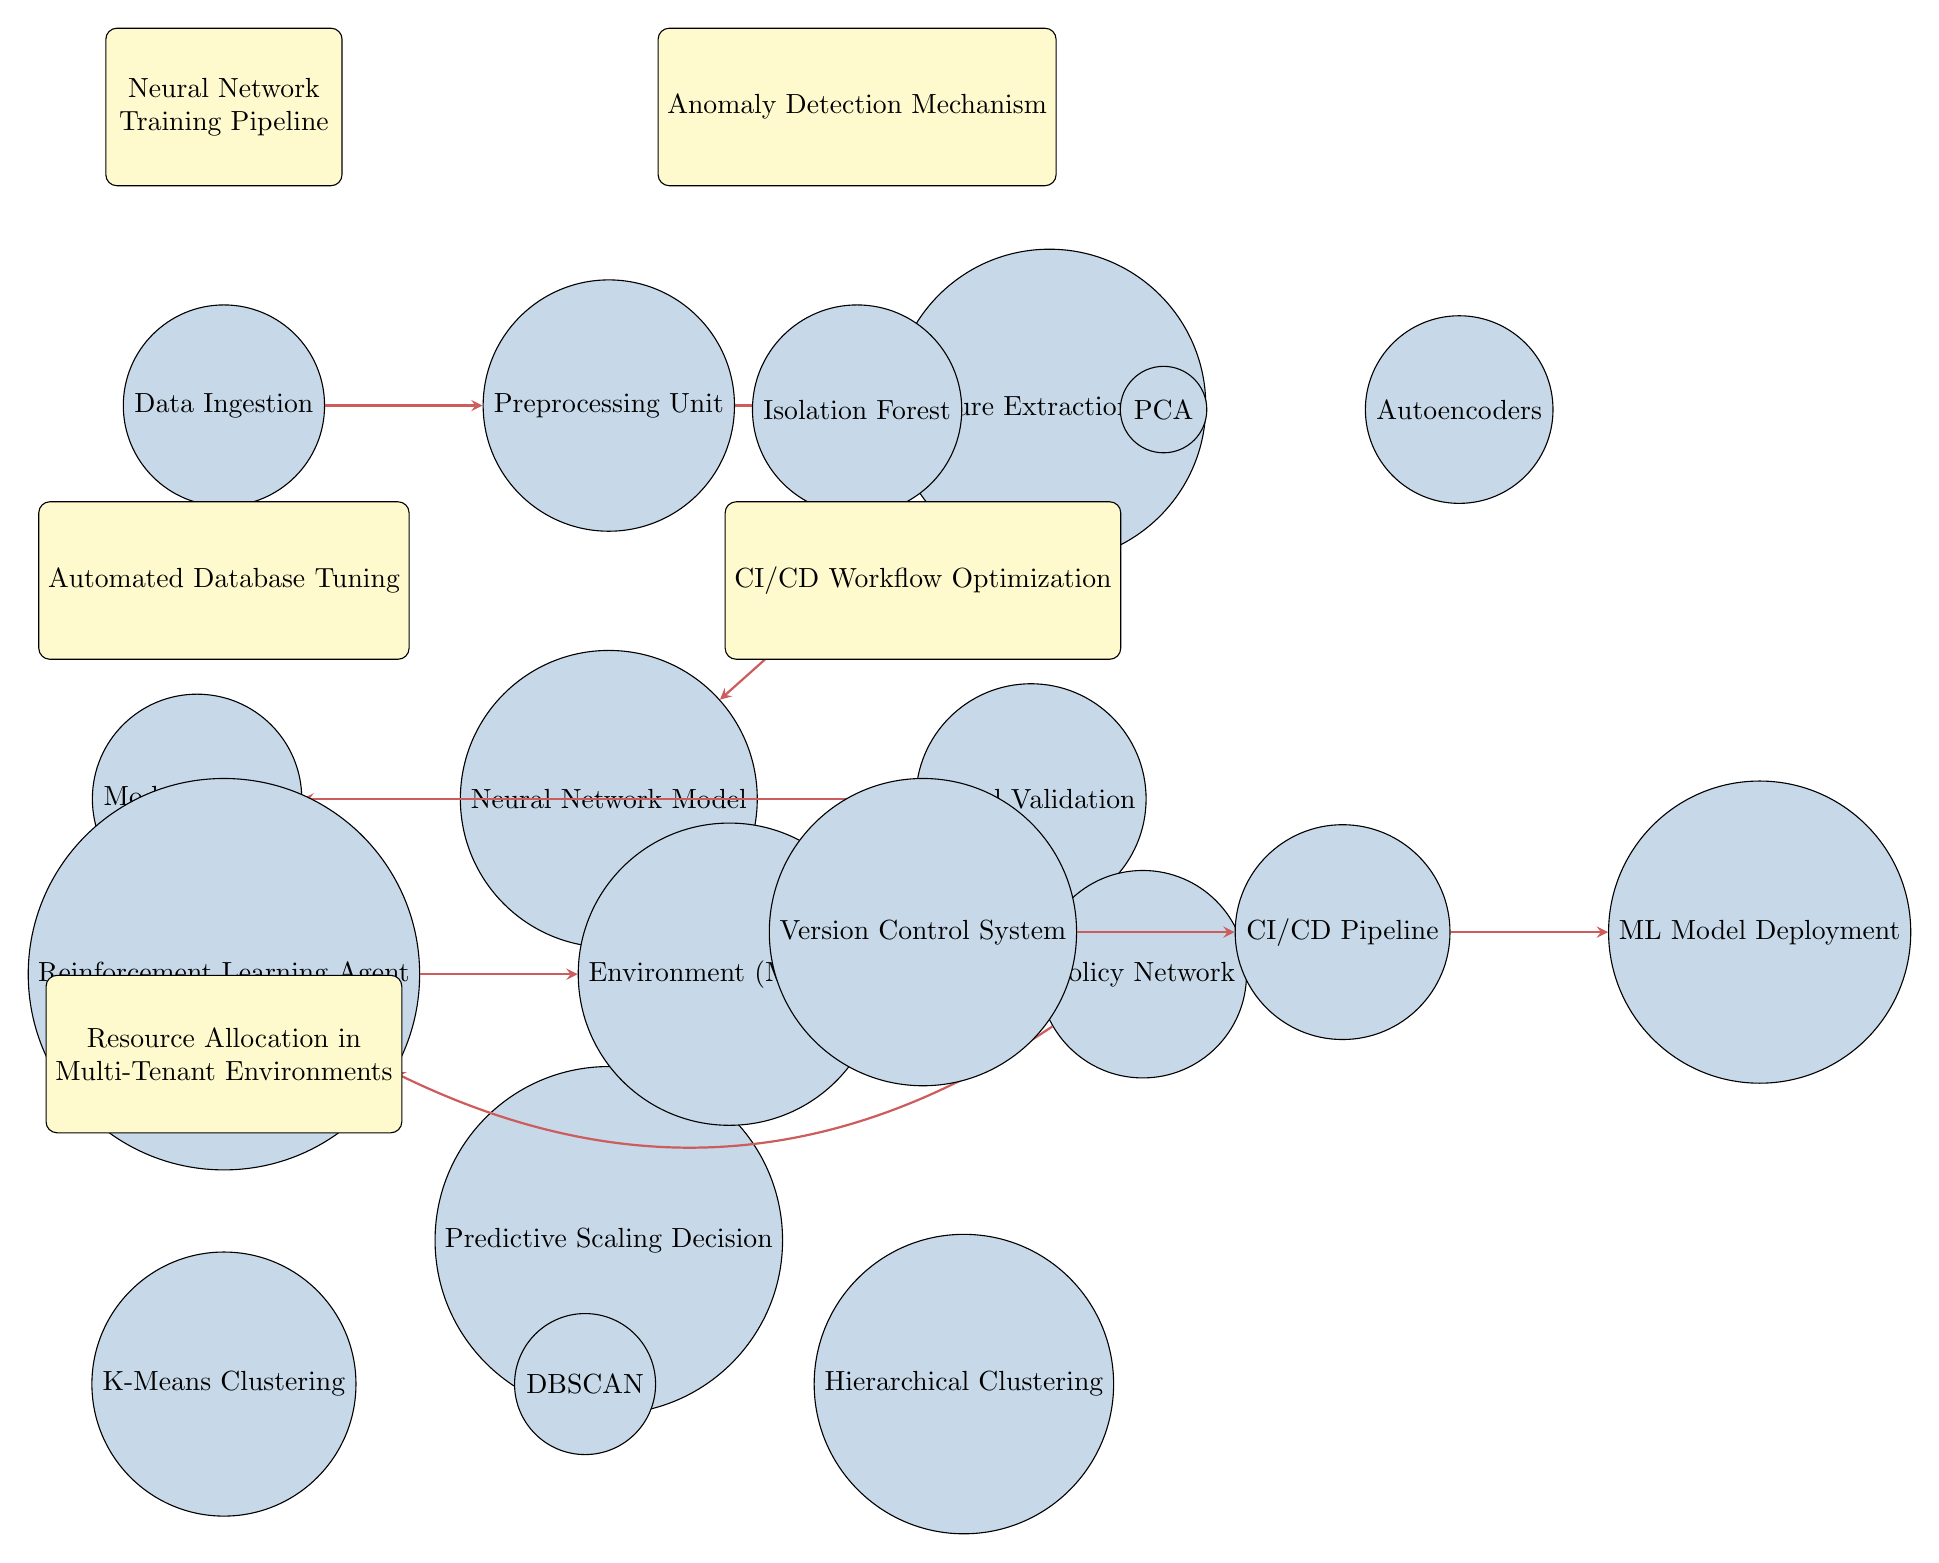What is the first step in the Neural Network Training Pipeline? The first step in the Neural Network Training Pipeline is represented by the node "Data Ingestion," which is located at the top of the pipeline.
Answer: Data Ingestion How many anomaly detection algorithms are shown in the diagram? There are three anomaly detection algorithms visualized in the diagram: Isolation Forest, PCA, and Autoencoders. Counting them results in a total of three.
Answer: Three Which component directly follows Feature Extraction Unit in the Neural Network Training Pipeline? The component that directly follows the Feature Extraction Unit in the diagram is the Neural Network Model, as indicated by the directional arrow from Feature Extraction Unit to Neural Network Model.
Answer: Neural Network Model What is the feedback loop in the Automated Database Tuning section? The feedback loop is represented by the arrows that connect the Reinforcement Learning Agent to the Environment (MySQL), and then from the Policy Network back to the Reinforcement Learning Agent. This illustrates a continuous interaction between these components.
Answer: Reinforcement Learning Agent What is the purpose of the Version Control System in the CI/CD Workflow Optimization? The Version Control System serves as the initial step in the CI/CD workflow, controlling versioning and integration of code before it proceeds through the pipeline. It ensures changes can be tracked and managed effectively during the workflow.
Answer: Version Control System Which clustering algorithm is positioned last in the Resource Allocation section? The last clustering algorithm mentioned in the Resource Allocation section of the diagram is Hierarchical Clustering, as it is the rightmost node positioned after K-Means Clustering and DBSCAN.
Answer: Hierarchical Clustering What is the relationship between Model Validation and Predictive Scaling Decision? Model Validation produces outcomes that are directed towards the Predictive Scaling Decision, implying that the validation process informs the decision-making about scaling actions based on the trained model's performance.
Answer: Model Validation to Predictive Scaling Decision How many main sections does the diagram encompass? The diagram incorporates five main sections, each labeled clearly: Neural Network Training Pipeline, Anomaly Detection Mechanism, Automated Database Tuning, CI/CD Workflow Optimization, and Resource Allocation in Multi-Tenant Environments.
Answer: Five 